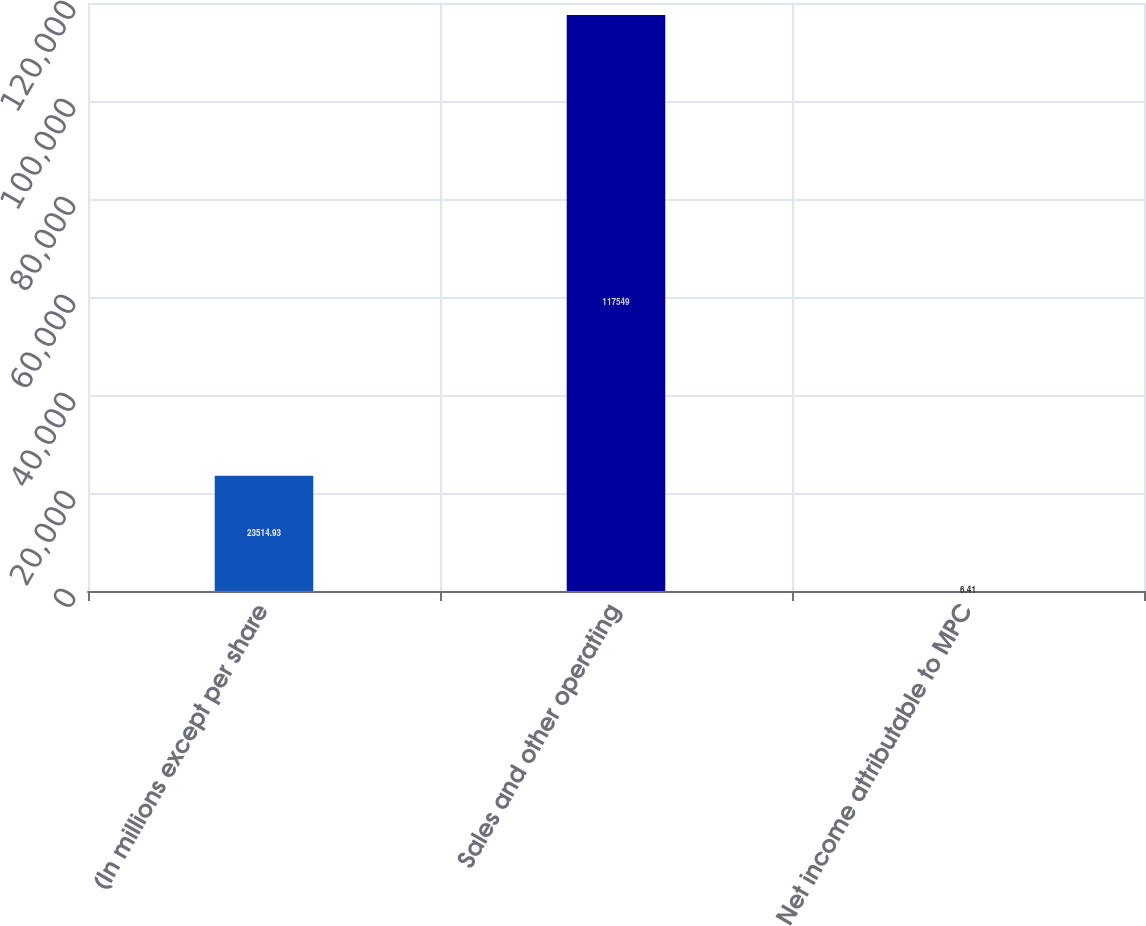<chart> <loc_0><loc_0><loc_500><loc_500><bar_chart><fcel>(In millions except per share<fcel>Sales and other operating<fcel>Net income attributable to MPC<nl><fcel>23514.9<fcel>117549<fcel>6.41<nl></chart> 